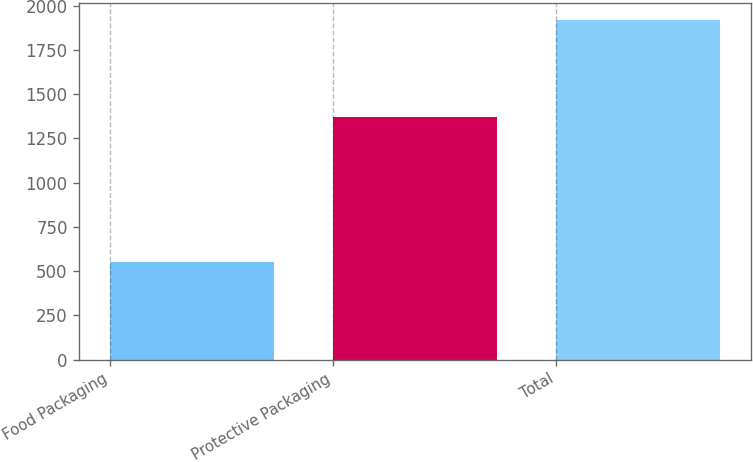Convert chart. <chart><loc_0><loc_0><loc_500><loc_500><bar_chart><fcel>Food Packaging<fcel>Protective Packaging<fcel>Total<nl><fcel>549.8<fcel>1368.2<fcel>1918<nl></chart> 